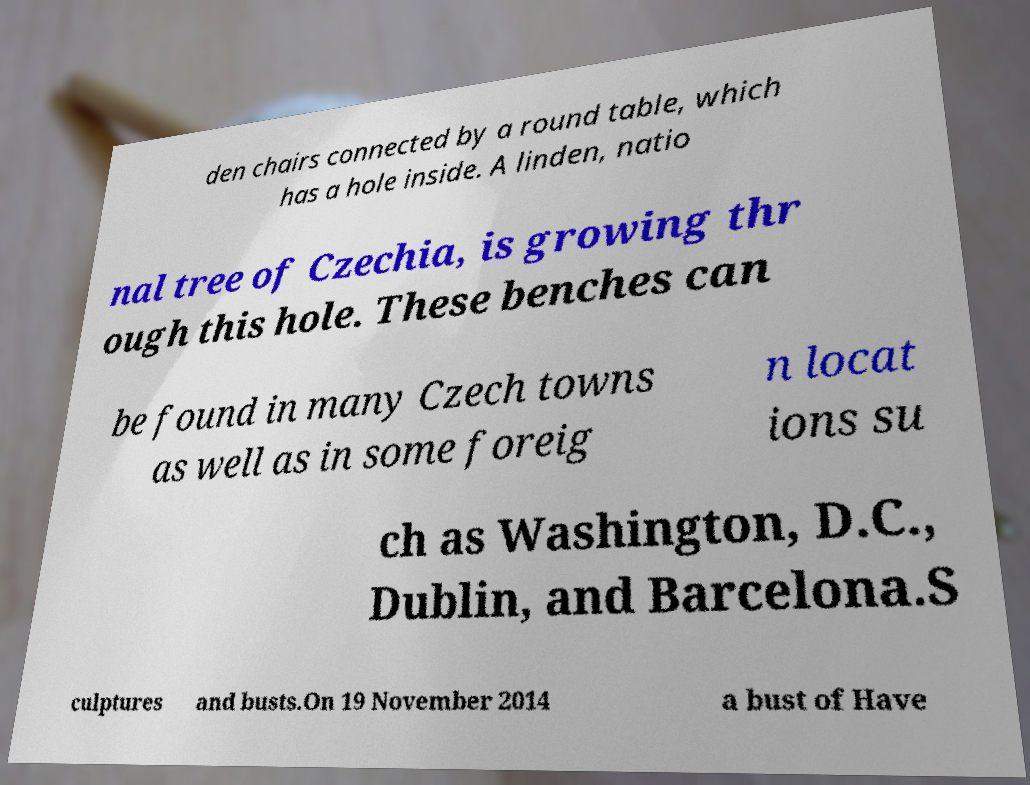Please identify and transcribe the text found in this image. den chairs connected by a round table, which has a hole inside. A linden, natio nal tree of Czechia, is growing thr ough this hole. These benches can be found in many Czech towns as well as in some foreig n locat ions su ch as Washington, D.C., Dublin, and Barcelona.S culptures and busts.On 19 November 2014 a bust of Have 